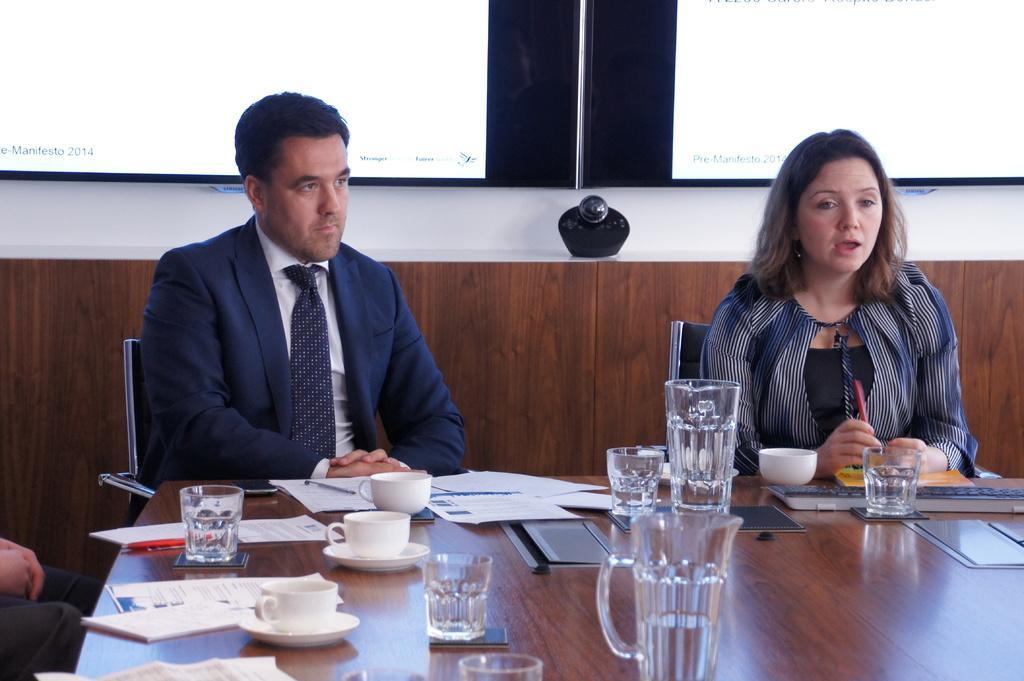Can you describe this image briefly? In this image, women and men are sat on the black chair. On left side we can see a human hand and legs. In the center of the image, there is a table. Some many items are placed on it. The background, we can see a screen. And right side woman is holding a pen. 